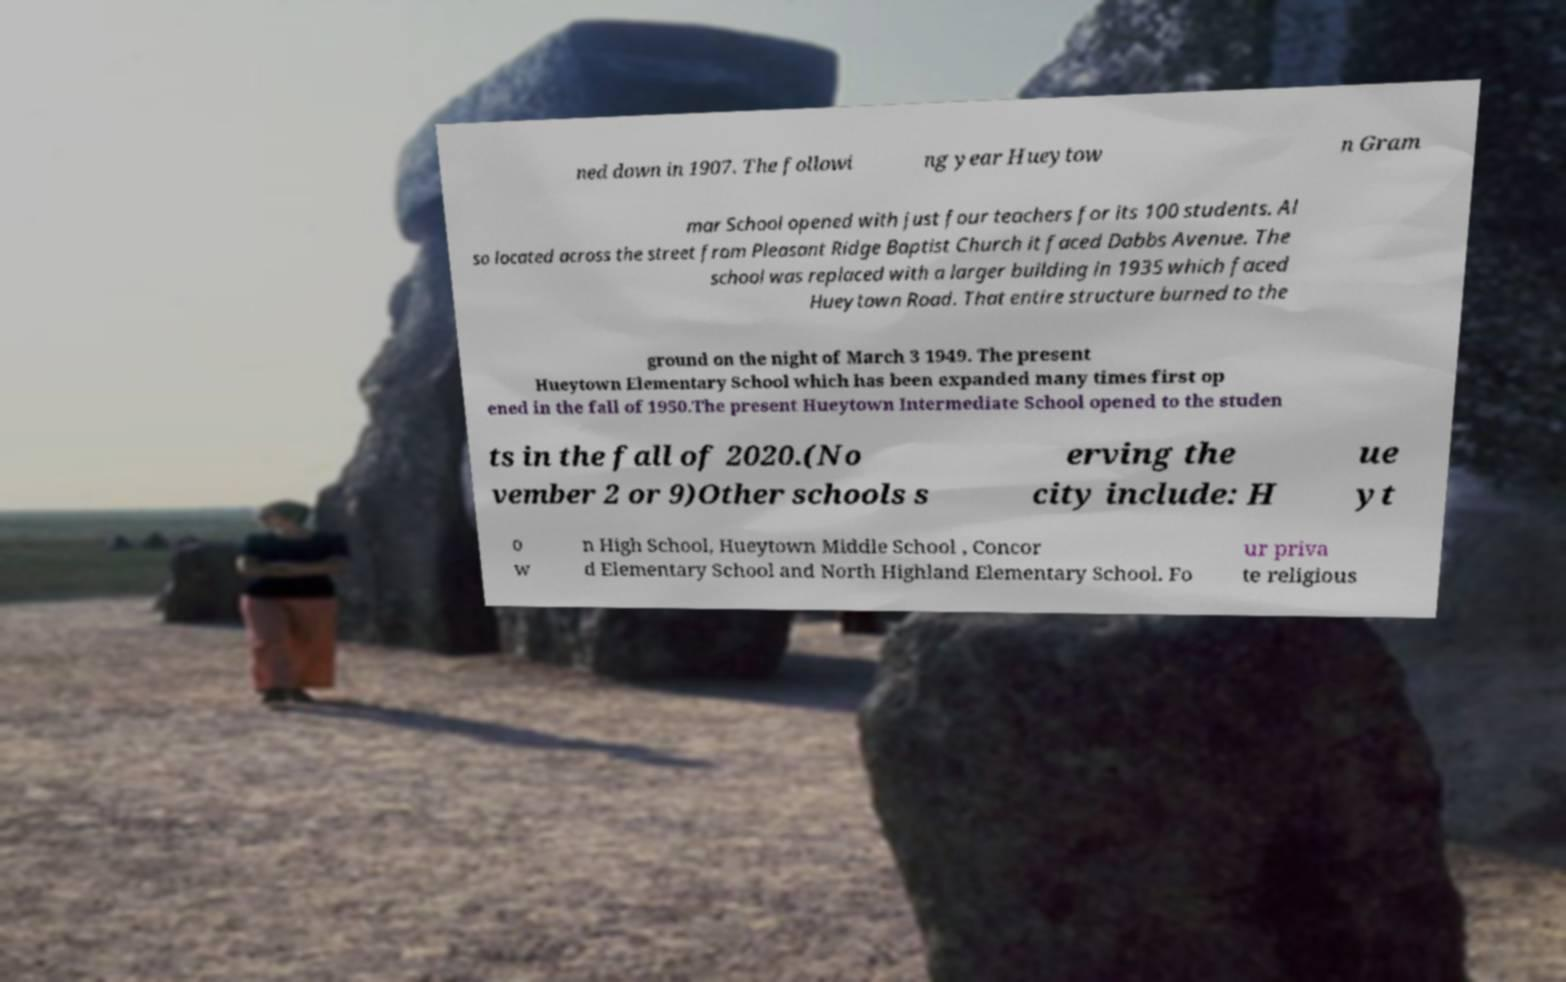Please identify and transcribe the text found in this image. ned down in 1907. The followi ng year Hueytow n Gram mar School opened with just four teachers for its 100 students. Al so located across the street from Pleasant Ridge Baptist Church it faced Dabbs Avenue. The school was replaced with a larger building in 1935 which faced Hueytown Road. That entire structure burned to the ground on the night of March 3 1949. The present Hueytown Elementary School which has been expanded many times first op ened in the fall of 1950.The present Hueytown Intermediate School opened to the studen ts in the fall of 2020.(No vember 2 or 9)Other schools s erving the city include: H ue yt o w n High School, Hueytown Middle School , Concor d Elementary School and North Highland Elementary School. Fo ur priva te religious 